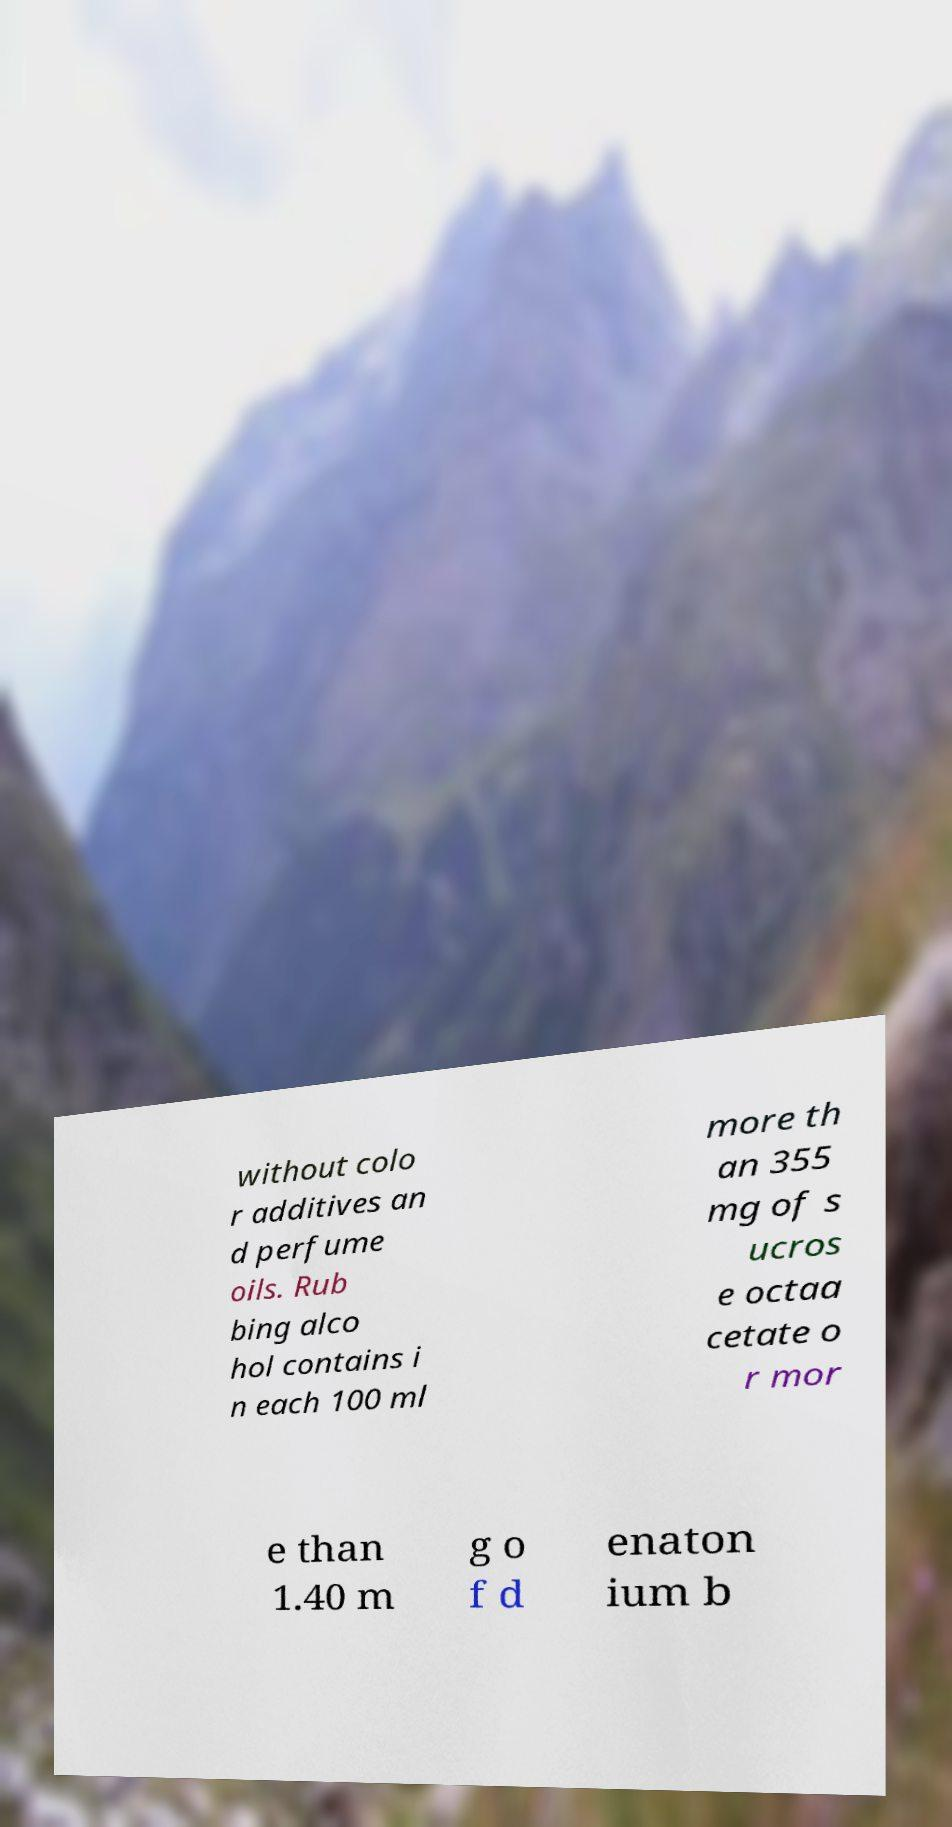Please read and relay the text visible in this image. What does it say? without colo r additives an d perfume oils. Rub bing alco hol contains i n each 100 ml more th an 355 mg of s ucros e octaa cetate o r mor e than 1.40 m g o f d enaton ium b 